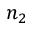Convert formula to latex. <formula><loc_0><loc_0><loc_500><loc_500>n _ { 2 }</formula> 